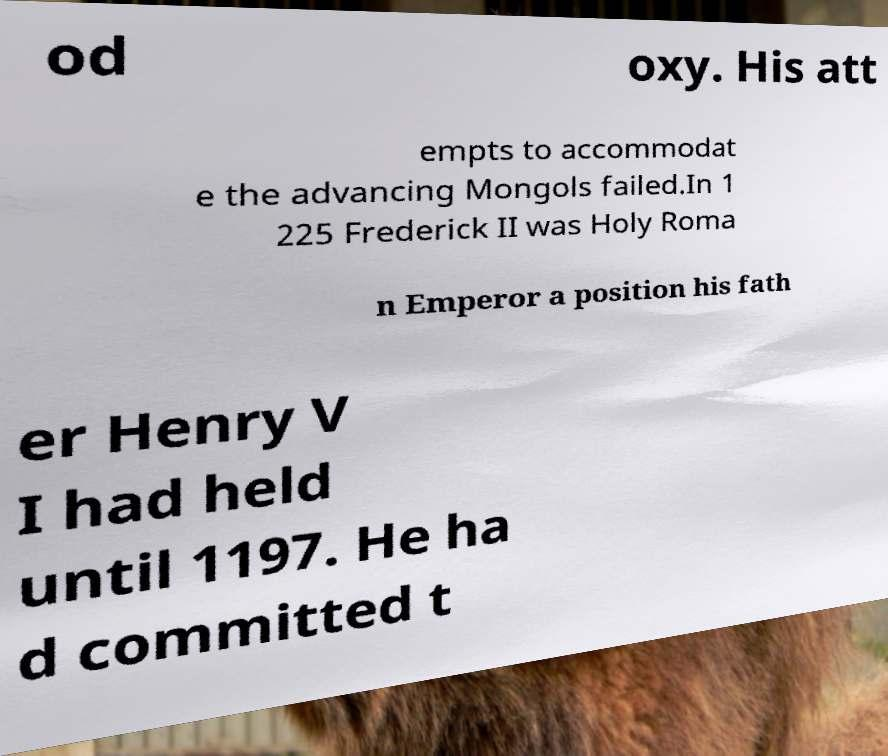Please read and relay the text visible in this image. What does it say? od oxy. His att empts to accommodat e the advancing Mongols failed.In 1 225 Frederick II was Holy Roma n Emperor a position his fath er Henry V I had held until 1197. He ha d committed t 